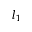<formula> <loc_0><loc_0><loc_500><loc_500>l _ { 1 }</formula> 